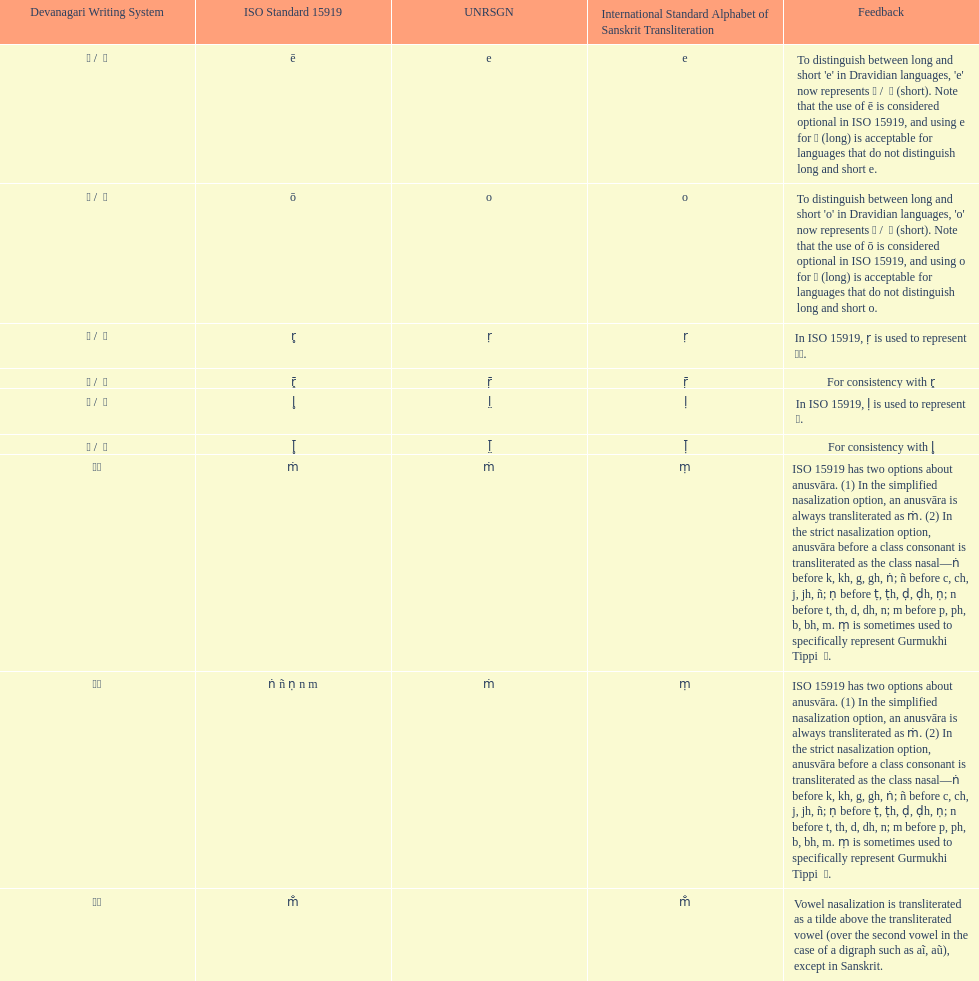What is the total number of translations? 8. 